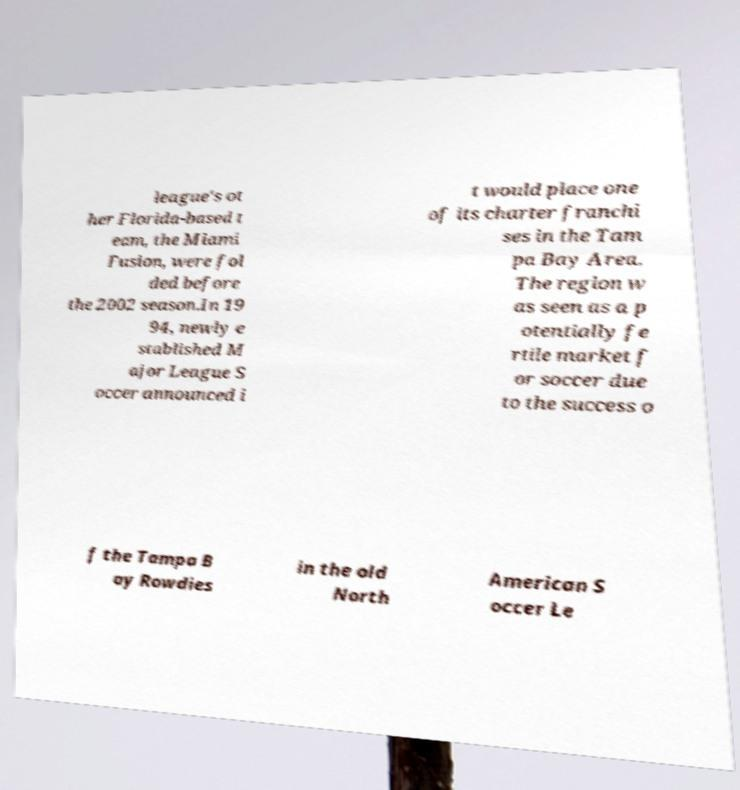Could you extract and type out the text from this image? league's ot her Florida-based t eam, the Miami Fusion, were fol ded before the 2002 season.In 19 94, newly e stablished M ajor League S occer announced i t would place one of its charter franchi ses in the Tam pa Bay Area. The region w as seen as a p otentially fe rtile market f or soccer due to the success o f the Tampa B ay Rowdies in the old North American S occer Le 